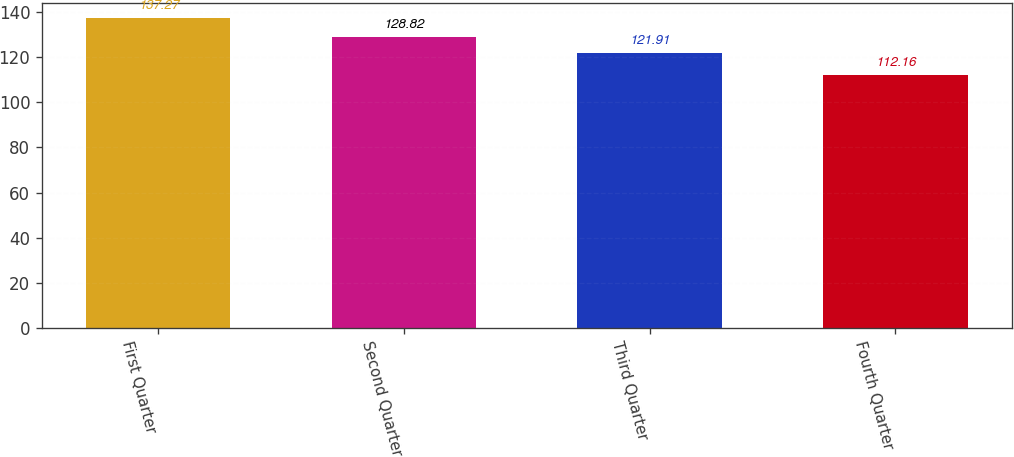<chart> <loc_0><loc_0><loc_500><loc_500><bar_chart><fcel>First Quarter<fcel>Second Quarter<fcel>Third Quarter<fcel>Fourth Quarter<nl><fcel>137.27<fcel>128.82<fcel>121.91<fcel>112.16<nl></chart> 